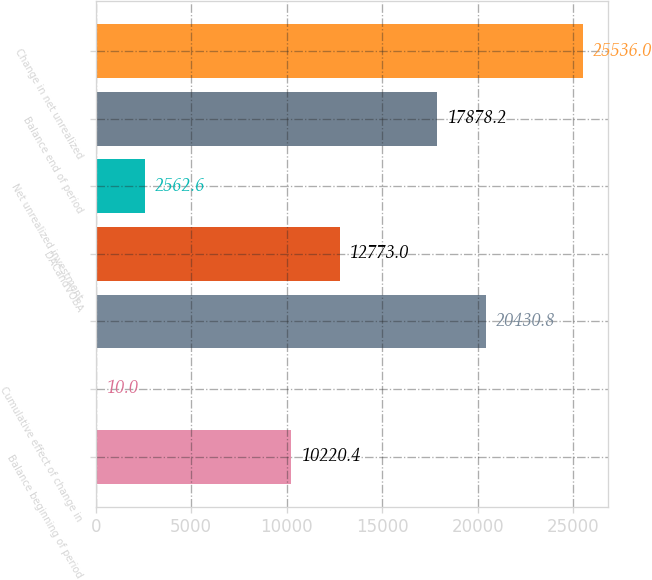<chart> <loc_0><loc_0><loc_500><loc_500><bar_chart><fcel>Balance beginning of period<fcel>Cumulative effect of change in<fcel>Unnamed: 2<fcel>DACandVOBA<fcel>Net unrealized investment<fcel>Balance end of period<fcel>Change in net unrealized<nl><fcel>10220.4<fcel>10<fcel>20430.8<fcel>12773<fcel>2562.6<fcel>17878.2<fcel>25536<nl></chart> 